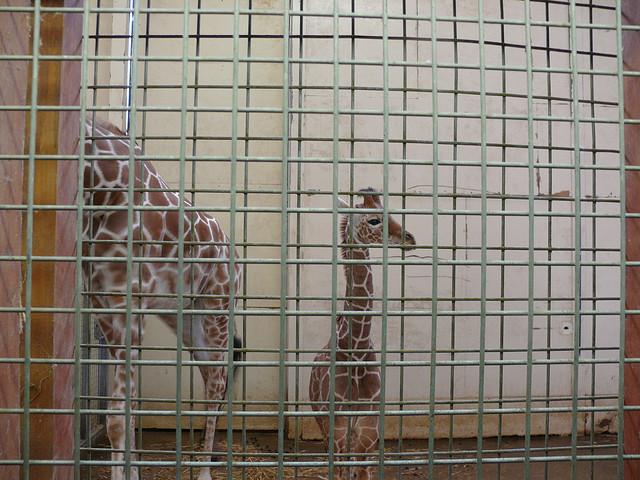What are the animals?
Keep it brief. Giraffes. Are the animals enclosed?
Keep it brief. Yes. Which animal is younger?
Give a very brief answer. One on right. What is inside the fence?
Be succinct. Giraffes. Is this a wooden fence?
Concise answer only. No. 